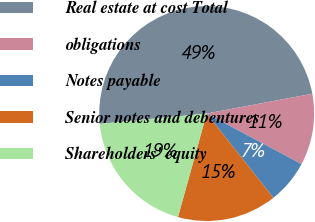<chart> <loc_0><loc_0><loc_500><loc_500><pie_chart><fcel>Real estate at cost Total<fcel>obligations<fcel>Notes payable<fcel>Senior notes and debentures<fcel>Shareholders' equity<nl><fcel>48.59%<fcel>10.75%<fcel>6.55%<fcel>14.96%<fcel>19.16%<nl></chart> 